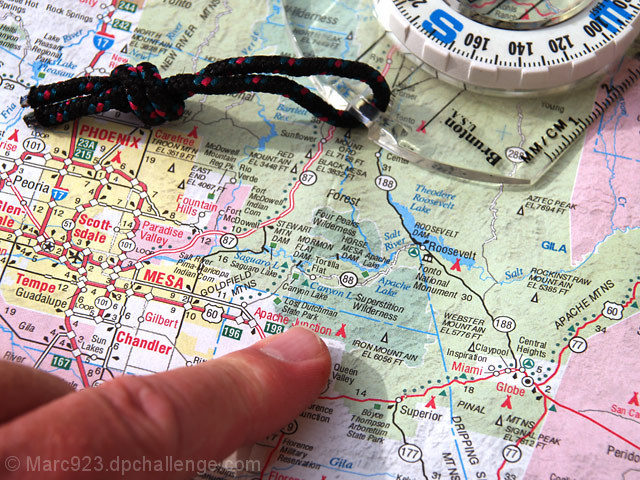Are the texture details of the main subject well preserved?
A. No
B. Yes
Answer with the option's letter from the given choices directly.
 B. 